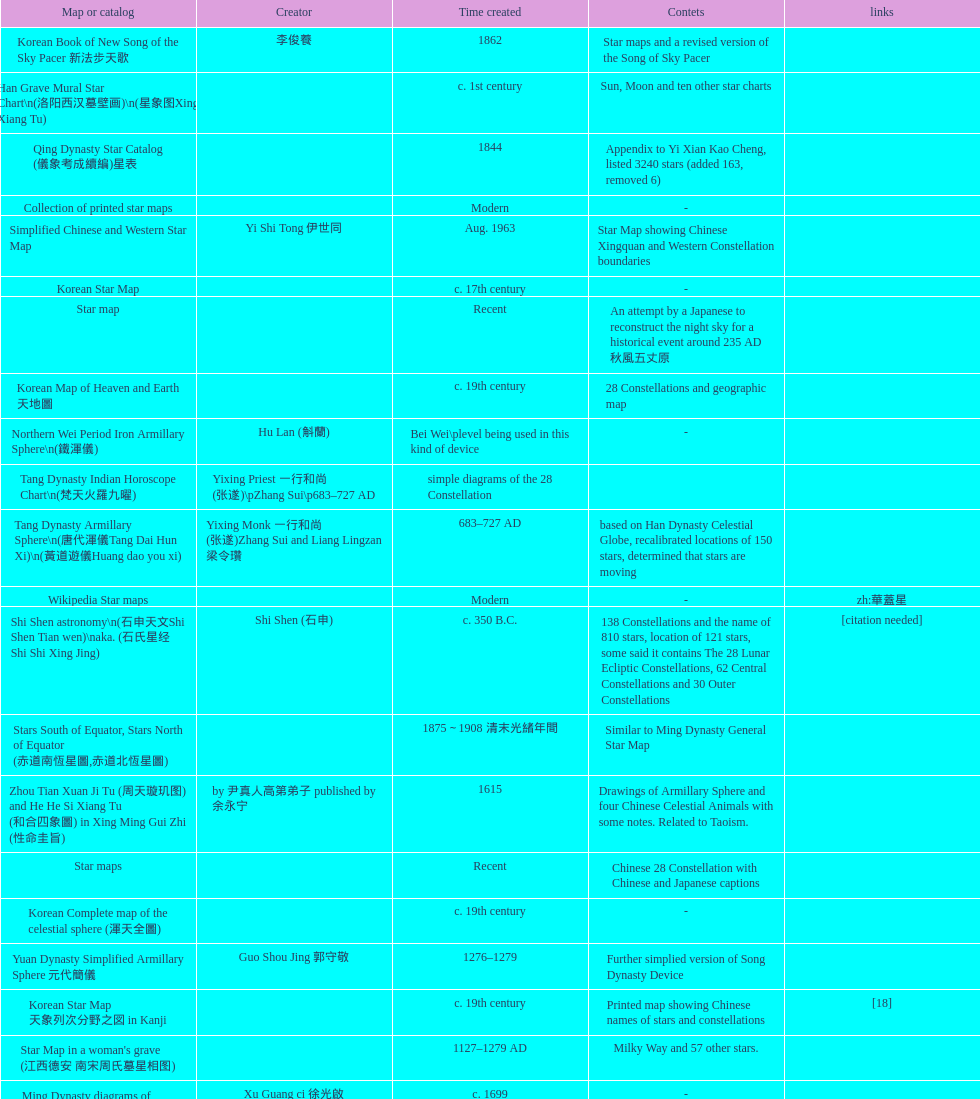When was the first map or catalog created? C. 4000 b.c. Parse the full table. {'header': ['Map or catalog', 'Creator', 'Time created', 'Contets', 'links'], 'rows': [['Korean Book of New Song of the Sky Pacer 新法步天歌', '李俊養', '1862', 'Star maps and a revised version of the Song of Sky Pacer', ''], ['Han Grave Mural Star Chart\\n(洛阳西汉墓壁画)\\n(星象图Xing Xiang Tu)', '', 'c. 1st century', 'Sun, Moon and ten other star charts', ''], ['Qing Dynasty Star Catalog (儀象考成續編)星表', '', '1844', 'Appendix to Yi Xian Kao Cheng, listed 3240 stars (added 163, removed 6)', ''], ['Collection of printed star maps', '', 'Modern', '-', ''], ['Simplified Chinese and Western Star Map', 'Yi Shi Tong 伊世同', 'Aug. 1963', 'Star Map showing Chinese Xingquan and Western Constellation boundaries', ''], ['Korean Star Map', '', 'c. 17th century', '-', ''], ['Star map', '', 'Recent', 'An attempt by a Japanese to reconstruct the night sky for a historical event around 235 AD 秋風五丈原', ''], ['Korean Map of Heaven and Earth 天地圖', '', 'c. 19th century', '28 Constellations and geographic map', ''], ['Northern Wei Period Iron Armillary Sphere\\n(鐵渾儀)', 'Hu Lan (斛蘭)', 'Bei Wei\\plevel being used in this kind of device', '-', ''], ['Tang Dynasty Indian Horoscope Chart\\n(梵天火羅九曜)', 'Yixing Priest 一行和尚 (张遂)\\pZhang Sui\\p683–727 AD', 'simple diagrams of the 28 Constellation', '', ''], ['Tang Dynasty Armillary Sphere\\n(唐代渾儀Tang Dai Hun Xi)\\n(黃道遊儀Huang dao you xi)', 'Yixing Monk 一行和尚 (张遂)Zhang Sui and Liang Lingzan 梁令瓚', '683–727 AD', 'based on Han Dynasty Celestial Globe, recalibrated locations of 150 stars, determined that stars are moving', ''], ['Wikipedia Star maps', '', 'Modern', '-', 'zh:華蓋星'], ['Shi Shen astronomy\\n(石申天文Shi Shen Tian wen)\\naka. (石氏星经 Shi Shi Xing Jing)', 'Shi Shen (石申)', 'c. 350 B.C.', '138 Constellations and the name of 810 stars, location of 121 stars, some said it contains The 28 Lunar Ecliptic Constellations, 62 Central Constellations and 30 Outer Constellations', '[citation needed]'], ['Stars South of Equator, Stars North of Equator (赤道南恆星圖,赤道北恆星圖)', '', '1875～1908 清末光緒年間', 'Similar to Ming Dynasty General Star Map', ''], ['Zhou Tian Xuan Ji Tu (周天璇玑图) and He He Si Xiang Tu (和合四象圖) in Xing Ming Gui Zhi (性命圭旨)', 'by 尹真人高第弟子 published by 余永宁', '1615', 'Drawings of Armillary Sphere and four Chinese Celestial Animals with some notes. Related to Taoism.', ''], ['Star maps', '', 'Recent', 'Chinese 28 Constellation with Chinese and Japanese captions', ''], ['Korean Complete map of the celestial sphere (渾天全圖)', '', 'c. 19th century', '-', ''], ['Yuan Dynasty Simplified Armillary Sphere 元代簡儀', 'Guo Shou Jing 郭守敬', '1276–1279', 'Further simplied version of Song Dynasty Device', ''], ['Korean Star Map 天象列次分野之図 in Kanji', '', 'c. 19th century', 'Printed map showing Chinese names of stars and constellations', '[18]'], ["Star Map in a woman's grave (江西德安 南宋周氏墓星相图)", '', '1127–1279 AD', 'Milky Way and 57 other stars.', ''], ['Ming Dynasty diagrams of Armillary spheres and Celestial Globes', 'Xu Guang ci 徐光啟', 'c. 1699', '-', ''], ['Sky Map', 'Yu Xi Dao Ren 玉溪道人', '1987', 'Star Map with captions', ''], ['Star Chart 清蒙文石刻(欽天監繪製天文圖) in Mongolia', '', '1727–1732 AD', '1550 stars grouped into 270 starisms.', ''], ['Tangut Khara-Khoto (The Black City) Star Map 西夏黑水城星圖', '', '940 AD', 'A typical Qian Lezhi Style Star Map', '-'], ['Korean version of 28 Constellation 列宿圖', '', 'c. 19th century', '28 Constellations, some named differently from their Chinese counterparts', ''], ['The Chinese Sky during the Han Constellating Stars and Society', 'Sun Xiaochun and Jacob Kistemaker', '1997 AD', 'An attempt to recreate night sky seen by Chinese 2000 years ago', ''], ['28 Xu Star map and catalog', '-', 'Modern', 'Stars around ecliptic', ''], ['Japanese Edo period Star Chart 天文分野之図', 'Harumi Shibukawa 渋川春海BuJingChun Mei (保井春海Bao JingChunMei)', '1677 延宝五年', '-', ''], ['North Sky Map 清嘉庆年间Huang Dao Zhong Xi He Tu(黄道中西合图)', 'Xu Choujun 徐朝俊', '1807 AD', 'More than 1000 stars and the 28 consellation', ''], ['The Dunhuang star map\\n(燉煌)', 'Dun Huang', '705–710 AD', '1,585 stars grouped into 257 clusters or "asterisms"', ''], ['Korean Star Maps, North and South to the Eclliptic 黃道南北恒星圖', '', '1742', '-', ''], ['Tang Dynasty Whole Sky Ecliptic Armillary Sphere\\n(渾天黃道儀)', 'Li Chunfeng 李淳風', '667 AD 貞觀七年', 'including Elliptic and Moon orbit, in addition to old equatorial design', '-'], ['Water-powered Planetarium\\n(水力渾天儀)', 'Geng Xun (耿詢)', 'c. 7th century 隋初Sui Chu', '-', '-'], ['Five Star Charts (新儀象法要)', 'Su Song 蘇頌', '1094 AD', '1464 stars grouped into 283 asterisms', 'Image:Su Song Star Map 1.JPG\\nImage:Su Song Star Map 2.JPG'], ['Japanese Edo period Star Chart 天球図説', '古筆源了材', '1835 天保6年', '-', '-'], ['Five Star Prediction Device\\n(安徽阜陽五星候占儀)', '', '168 BC', 'Also an Equatorial Device', '[citation needed]'], ['Japanese Star Map 天象一覧図 in Kanji', '桜田虎門', '1824 AD 文政７年', 'Printed map showing Chinese names of stars and constellations', ''], ['Ming Dynasty Planetarium Machine (渾象 Hui Xiang)', '', 'c. 17th century', 'Ecliptic, Equator, and dividers of 28 constellation', ''], ['Fuxi 64 gua 28 xu wood carving 天水市卦台山伏羲六十四卦二十八宿全图', '', 'modern', '-', '-'], ['Reproduction of an ancient device 璇璣玉衡', 'Dai Zhen 戴震', '1723–1777 AD', 'based on ancient record and his own interpretation', 'Could be similar to'], ['Stars map (恒星赤道経緯度図)stored in Japan', '', '1844 道光24年 or 1848', '-', '-'], ['Reproduced Hun Tian Yi\\n(浑天仪)\\nand wrote\\nHun Tian Xiang Shuo\\n(浑天象说)', 'Wang Fan 王蕃', '227–266 AD 三国', '-', '-'], ['Star Map with illustrations for Xingguans', '坐井★观星Zuo Jing Guan Xing', 'Modern', 'illustrations for cylindrical and circular polar maps', ''], ['Northern Wei Grave Dome Star Map\\n(河南洛陽北魏墓頂星圖)', '', '526 AD 北魏孝昌二年', 'about 300 stars, including the Big Dipper, some stars are linked by straight lines to form constellation. The Milky Way is also shown.', ''], ['Song Dynasty Armillary Sphere 北宋簡化渾儀', 'Shen Kuo 沈括 and Huangfu Yu 皇甫愈', '1089 AD 熙寧七年', 'Simplied version of Tang Dynasty Device, removed the rarely used moon orbit.', '-'], ['Korean Star maps: Star Map South to the Ecliptic 黃道南恒星圖 and Star Map South to the Ecliptic 黃道北恒星圖', '', 'c. 19th century', 'Perhaps influenced by Adam Schall von Bell Tang Ruo wang 湯若望 (1591–1666) and P. Ignatius Koegler 戴進賢 (1680–1748)', ''], ['Warring States Period grave lacquer box\\n(戰國初年湖北隨縣擂鼓墩曾侯乙墓漆箱)', '', 'c. 5th century BC', 'Indicated location of Big Dipper and 28 Constellations by characters', ''], ['Star Chart 五代吳越文穆王前元瓘墓石刻星象圖', '', '941–960 AD', '-', ''], ['Star Chart', 'Mao Kun 茅坤', 'c. 1422', 'Polaris compared with Southern Cross and Alpha Centauri', 'zh:郑和航海图'], ['Japanese Edo period Star Chart 天象総星之図', 'Chao Ye Bei Shui 朝野北水', '1814 文化十一年', '-', '-'], ['First Ecliptic Armillary Sphere\\n(黄道仪Huang Dao Yi)', 'Jia Kui 贾逵', '30–101 AD 东汉永元十五年', '-', '-'], ['Japanese Edo period Star Chart 星図歩天歌', '小島好謙 and 鈴木世孝', '1824 文政七年', '-', '-'], ['Stellarium Chinese and Korean Sky Culture', 'G.S.K. Lee; Jeong, Tae-Min(jtm71); Yu-Pu Wang (evanzxcv)', 'Modern', 'Major Xingguans and Star names', ''], ['Copper Plate Star Map stored in Korea', '', '1652 順治九年shun zi jiu nian', '-', ''], ['Jingban Tianwen Quantu by Ma Junliang 马俊良', '', '1780–90 AD', 'mapping nations to the sky', ''], ['Japanese Edo period Star Chart 天象列次之図 based on 天象列次分野之図 from Korean', 'Harumi Shibukawa 渋川春海Bu Chuan Chun Mei(保井春海Bao Jing Chun Mei)', '1670 寛文十年', '-', ''], ['Korean star map in stone', '', '1687', '-', ''], ['Chanshu Star Chart (明常熟石刻天文圖)', '', '1506', 'Based on Suzhou Star Chart, Northern Sky observed at 36.8 degrees North Latitude, 1466 stars grouped into 284 asterism', '-'], ["Korean King Sejong's Armillary sphere", '', '1433', '-', ''], ['AEEA Star maps', '', 'Modern', 'Good reconstruction and explanation of Chinese constellations', ''], ['Japanese Star Chart 梅園星図', '高橋景保', '-', '-', ''], ['Japanese Edo period Illustration of a Star Measuring Device 平天儀図解', 'Yan Qiao Shan Bing Heng 岩橋善兵衛', '1802 Xiang He Er Nian 享和二年', '-', 'The device could be similar to'], ['Equatorial Armillary Sphere\\n(渾儀Hun Xi)', 'Kong Ting (孔挺)', '323 AD 東晉 前趙光初六年', 'level being used in this kind of device', '-'], ['Korean Tomb', '', 'c. late 14th century', 'Big Dipper', ''], ['Japanese Edo period Star Chart 新制天球星象記', '田中政均', '1815 文化十二年', '-', '-'], ['Prajvalonisa Vjrabhairava Padvinasa-sri-dharani Scroll found in Japan 熾盛光佛頂大威德銷災吉祥陀羅尼經卷首扉畫', '', '972 AD 北宋開寶五年', 'Chinese 28 Constellations and Western Zodiac', '-'], ['M45 (伏羲星图Fuxixingtu)', '', 'c. 4000 B.C.', 'Found in a mural in a Neolithic Grave in Henan Puyang (河南濮陽西水坡新石器時代古墓) clam shells arranged in the shape of Big Dipper in the North (北斗Bei Dou) and below the foot, Tiger in the West and Azure Dragon in the East. Also showing Five Stars.', '[citation needed]'], ['Japanese Edo period Star Chart 方円星図,方圓星図 and 増補分度星図方図', '石坂常堅', '1826b文政9年', '-', '-'], ['The Celestial Globe 清康熙 天體儀', 'Ferdinand Verbiest 南懷仁', '1673', '1876 stars grouped into 282 asterisms', ''], ['Japanese Star Chart 天体図', '三浦梅園', '-', '-', '-'], ['Big Dipper\\n(山東嘉祥武梁寺石刻北斗星)', '', '–', 'showing stars in Big Dipper', ''], ['Korean Star Map Cube 方星圖', 'Italian Missionary Philippus Maria Grimardi 閔明我 (1639~1712)', 'c. early 18th century', '-', ''], ['Japanese Edo period Star Chart', '鈴木世孝', '1824 文政七年', '-', '-'], ['Picture depicted Song Dynasty fictional astronomer (呉用 Wu Yong) with a Celestial Globe (天體儀)', 'Japanese painter', '1675', 'showing top portion of a Celestial Globe', 'File:Chinese astronomer 1675.jpg'], ['Han Comet Diagrams\\n(湖南長沙馬王堆漢墓帛書)\\n(彗星圖Meng xing Tu)', '', '193 BC', 'Different 29 different types of comets, also record and prediction of positions of Jupiter, Saturn, and Venus during 246–177 B.C.', ''], ['Korean Complete Star Map (渾天全圖)', '', 'c. 18th century', '-', ''], ['Whole Sky Star Maps\\n(全天星圖Quan Tian Xing Tu)', 'Chen Zhuo (陳卓)', 'c. 270 AD 西晉初Xi Jin Chu', 'A Unified Constellation System. Star maps containing 1464 stars in 284 Constellations, written astrology text', '-'], ['Ming Ancient Star Chart 北京隆福寺(古星圖)', '', 'c. 1453 明代', '1420 Stars, possibly based on old star maps from Tang Dynasty', ''], ['Hun Tian Yi Tong Xing Xiang Quan Tu, Suzhou Star Chart (蘇州石刻天文圖),淳祐天文図', 'Huang Shang (黃裳)', 'created in 1193, etched to stone in 1247 by Wang Zhi Yuan 王致遠', '1434 Stars grouped into 280 Asterisms in Northern Sky map', ''], ['First remark of a constellation in observation in Korean history', '', '49 BC 혁거세 거서간 9년', "The star 'Pae'(a kind of comet) appeared in the constellation Wang Rang", 'Samguk Sagi'], ['Korean Book of Stars 經星', '', 'c. 19th century', 'Several star maps', ''], ['Liao Dynasty Tomb Dome Star Map 遼宣化张世卿墓頂星圖', '', '1116 AD 遼天庆六年', 'shown both the Chinese 28 Constellation encircled by Babylonian Zodiac', ''], ['SinoSky Beta 2.0', '', '2002', 'A computer program capable of showing Chinese Xingguans alongside with western constellations, lists about 700 stars with Chinese names.', ''], ['Korean Star Map Stone', '', 'c. 17th century', '-', ''], ['Korean Astronomy Book "Selected and Systematized Astronomy Notes" 天文類抄', '', '1623~1649', 'Contained some star maps', ''], ['Wu Xian Star Map\\n(商巫咸星圖Shang wu Jian xing Tu)', 'Wu Xian', 'c. 1000 BC', 'Contained 44 Central and Outer constellations totalling 141 stars', '[citation needed]'], ['Japanese Star Chart 改正天文図説', '', 'unknown', 'Included stars from Harumi Shibukawa', ''], ['天象列次分野之図(Cheonsang Yeolcha Bunyajido)', '', '1395', 'Korean versions of Star Map in Stone. It was made in Chosun Dynasty and the constellation names were written in Chinese letter. The constellations as this was found in Japanese later. Contained 1,464 stars.', ''], ['Japanese Edo period Star Chart 昊天図説詳解', '佐藤祐之', '1824 文政七年', '-', '-'], ['Turfan Tomb Star Mural\\n(新疆吐鲁番阿斯塔那天文壁画)', '', '250–799 AD 唐', '28 Constellations, Milkyway and Five Stars', ''], ['Japanese Edo period Star Chart 天文図解', '井口常範', '1689 元禄2年', '-', '-'], ['Treatise on Astrology of the Kaiyuan Era\\n(開元占経,开元占经Kai Yuan zhang Jing)', 'Gautama Siddha', '713 AD –', 'Collection of the three old star charts from Shi Shen, Gan De and Wu Xian. One of the most renowned collection recognized academically.', '-'], ['HNSKY Korean/Chinese Supplement', 'Jeong, Tae-Min(jtm71)/Chuang_Siau_Chin', 'Modern', 'Korean supplement is based on CheonSangYeulChaBunYaZiDo (B.C.100 ~ A.D.100)', ''], ['Southern Dynasties Period Whole Sky Planetarium\\n(渾天象Hun Tian Xiang)', 'Qian Lezhi (錢樂之)', '443 AD 南朝劉宋元嘉年間', 'used red, black and white to differentiate stars from different star maps from Shi Shen, Gan De and Wu Xian 甘, 石, 巫三家星', '-'], ['Japanese Edo period Star Measuring Device 中星儀', '足立信順Zhu Li Xin Shun', '1824 文政七年', '-', '-'], ['Tian Wun Tu (天问图)', 'Xiao Yun Cong 萧云从', 'c. 1600', 'Contained mapping of 12 constellations and 12 animals', ''], ['Japanese star chart', 'Harumi Yasui written in Chinese', '1699 AD', 'A Japanese star chart of 1699 showing lunar stations', ''], ['Sky in Google Earth KML', '', 'Modern', 'Attempts to show Chinese Star Maps on Google Earth', ''], ['Ming Dynasty Star Map (渾蓋通憲圖說)', 'Matteo Ricci 利玛窦Li Ma Dou, recorded by Li Zhizao 李之藻', 'c. 1550', '-', ''], ['Japanese Edo period Star Chart 天文成象Tian Wen Cheng xiang', '(渋川昔尹She Chuan Xi Yin) (保井昔尹Bao Jing Xi Yin)', '1699 元禄十二年', 'including Stars from Wu Shien (44 Constellation, 144 stars) in yellow; Gan De (118 Constellations, 511 stars) in black; Shi Shen (138 Constellations, 810 stars) in red and Harumi Shibukawa (61 Constellations, 308 stars) in blue;', ''], ['Ancient Star Map 先天图 by 陈抟Chen Tuan', '', 'c. 11th Chen Tuan 宋Song', 'Perhaps based on studying of Puyong Ancient Star Map', 'Lost'], ['Qing Dynasty Star Catalog (儀象考成,仪象考成)恒星表 and Star Map 黄道南北両星総図', 'Yun Lu 允禄 and Ignatius Kogler 戴进贤Dai Jin Xian 戴進賢, a German', 'Device made in 1744, book completed in 1757 清乾隆年间', '300 Constellations and 3083 Stars. Referenced Star Catalogue published by John Flamsteed', ''], ['Astronomic star observation\\n(天文星占Tian Wen xing zhan)', 'Gan De (甘德)', '475-221 B.C.', 'Contained 75 Central Constellation and 42 Outer Constellations, some said 510 stars in 18 Constellations', '[citation needed]'], ['Ming Dynasty General Star Map (赤道南北兩總星圖)', 'Xu Guang ci 徐光啟 and Adam Schall von Bell Tang Ruo Wang湯若望', '1634', '-', ''], ['Ceramic Ink Sink Cover', '', 'c. 17th century', 'Showing Big Dipper', ''], ['Korean Star Map', '', 'c. 19th century, late Choson Period', '-', ''], ['Japanese Edo period Star Chart 古暦便覧備考', '苗村丈伯Mao Chun Zhang Bo', '1692 元禄5年', '-', '-'], ['Kitora Kofun 法隆寺FaLong Si\u3000キトラ古墳 in Japan', '', 'c. late 7th century – early 8th century', 'Detailed whole sky map', ''], ['修真內外火侯全圖 Huo Hou Tu', 'Xi Chun Sheng Chong Hui\\p2005 redrawn, original unknown', 'illustrations of Milkyway and star maps, Chinese constellations in Taoism view', '', ''], ['Korean Star Chart 渾天図', '朴?', '-', '-', '-'], ['Celestial Globe\\n(渾象)\\n(圓儀)', 'Geng Shouchang (耿壽昌)', '52 BC 甘露二年Gan Lu Er Ren', 'lost', '[citation needed]'], ['Lingtai Miyuan\\n(靈台秘苑)', 'Yu Jicai (庾季才) and Zhou Fen (周墳)', '604 AD 隋Sui', 'incorporated star maps from different sources', '-'], ['Song Dynasty Bronze Armillary Sphere 北宋至道銅渾儀', 'Han Xianfu 韓顯符', '1006 AD 宋道元年十二月', 'Similar to the Simplified Armillary by Kong Ting 孔挺, 晁崇 Chao Chong, 斛蘭 Hu Lan', '-'], ['Japanese Edo period Star Chart 天経或問註解図巻\u3000下', '入江脩敬Ru Jiang YOu Jing', '1750 寛延3年', '-', '-'], ['Star Chart in a Dao Temple 玉皇山道觀星圖', '', '1940 AD', '-', '-'], ['Japanese Edo period Star Chart 経緯簡儀用法', '藤岡有貞', '1845 弘化２年', '-', '-'], ['Japanese Star Chart 瀧谷寺 天之図', '', 'c. 14th or 15th centuries 室町中期以前', '-', ''], ['Picture of Fuxi and Nüwa 新疆阿斯達那唐墓伏羲Fu Xi 女媧NV Wa像Xiang', '', 'Tang Dynasty', 'Picture of Fuxi and Nuwa together with some constellations', 'Image:Nuva fuxi.gif'], ['Song Dynasty Water-powered Planetarium 宋代 水运仪象台', 'Su Song 蘇頌 and Han Gonglian 韩公廉', 'c. 11th century', '-', ''], ['Equatorial Armillary Sphere\\n(赤道式渾儀)', 'Luo Xiahong (落下閎)', '104 BC 西漢武帝時', 'lost', '[citation needed]'], ['Rock Star Chart 清代天文石', '', 'c. 18th century', 'A Star Chart and general Astronomy Text', ''], ['Sky Map\\n(浑天图)\\nand\\nHun Tian Yi Shuo\\n(浑天仪说)', 'Lu Ji (陆绩)', '187–219 AD 三国', '-', '-'], ['Japanese Edo period Star Chart 分野星図', '高塚福昌, 阿部比輔, 上条景弘', '1849 嘉永2年', '-', '-'], ['Chinese Star map', 'John Reeves esq', '1819 AD', 'Printed map showing Chinese names of stars and constellations', ''], ['Japanese Star Chart 格子月進図', '', '1324', 'Similar to Su Song Star Chart, original burned in air raids during World War II, only pictures left. Reprinted in 1984 by 佐佐木英治', ''], ['Japanese Edo period Star Chart 天球図', '坂部廣胖', '1816 文化十三年', '-', '-'], ['28 Constellations, big dipper and 4 symbols Star map', '', 'Modern', '-', ''], ['Japanese Star Chart', '伊能忠誨', 'c. 19th century', '-', '-'], ['Han Dynasty Nanyang Stone Engraving\\n(河南南阳汉石刻画)\\n(行雨图Xing Yu Tu)', '', 'c. 1st century', 'Depicted five stars forming a cross', ''], ['Japanese Late Edo period Star Chart 天文図屏風', '遠藤盛俊', 'late Edo Period 江戸時代後期', '-', '-'], ['Star Chart preserved in Japan based on a book from China 天経或問', 'You Zi liu 游子六', '1730 AD 江戸時代 享保15年', 'A Northern Sky Chart in Chinese', ''], ['Eastern Han Celestial Globe and star maps\\n(浑天仪)\\n(渾天儀圖注,浑天仪图注)\\n(靈憲,灵宪)', 'Zhang Heng (张衡)', '117 AD', '-', '-'], ['Song Dynasty Bronze Armillary Sphere 北宋天文院黄道渾儀', 'Shu Yijian 舒易簡, Yu Yuan 于渊, Zhou Cong 周琮', '宋皇祐年中', 'Similar to the Armillary by Tang Dynasty Liang Lingzan 梁令瓚 and Yi Xing 一行', '-'], ['Japanese Edo period Star Chart 天象管鈔 天体図 (天文星象図解)', '長久保赤水', '1824 文政七年', '-', '']]} 